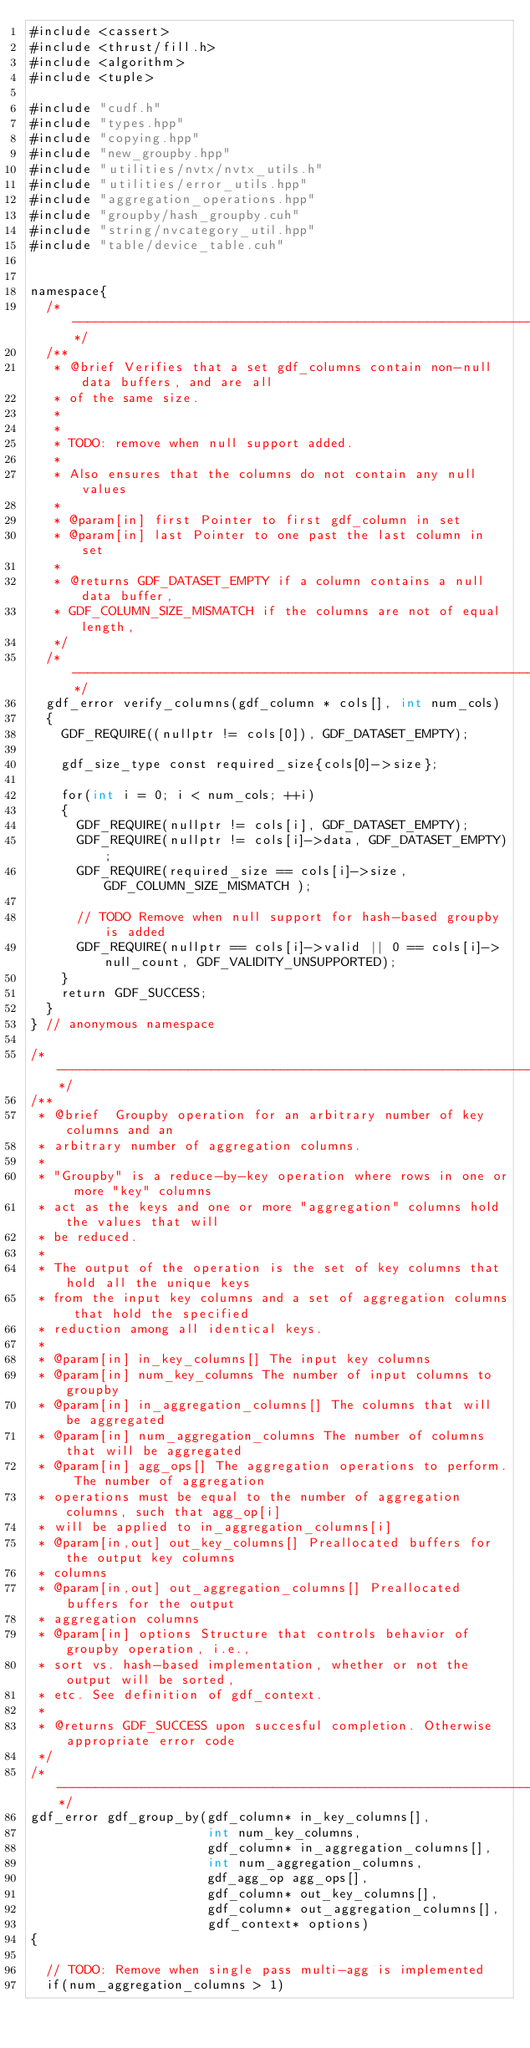<code> <loc_0><loc_0><loc_500><loc_500><_Cuda_>#include <cassert>
#include <thrust/fill.h>
#include <algorithm>
#include <tuple>

#include "cudf.h"
#include "types.hpp"
#include "copying.hpp"
#include "new_groupby.hpp"
#include "utilities/nvtx/nvtx_utils.h"
#include "utilities/error_utils.hpp"
#include "aggregation_operations.hpp"
#include "groupby/hash_groupby.cuh"
#include "string/nvcategory_util.hpp"
#include "table/device_table.cuh"


namespace{
  /* --------------------------------------------------------------------------*/
  /**
   * @brief Verifies that a set gdf_columns contain non-null data buffers, and are all
   * of the same size.
   *
   *
   * TODO: remove when null support added.
   *
   * Also ensures that the columns do not contain any null values
   *
   * @param[in] first Pointer to first gdf_column in set
   * @param[in] last Pointer to one past the last column in set
   *
   * @returns GDF_DATASET_EMPTY if a column contains a null data buffer,
   * GDF_COLUMN_SIZE_MISMATCH if the columns are not of equal length,
   */
  /* ----------------------------------------------------------------------------*/
  gdf_error verify_columns(gdf_column * cols[], int num_cols)
  {
    GDF_REQUIRE((nullptr != cols[0]), GDF_DATASET_EMPTY);

    gdf_size_type const required_size{cols[0]->size};

    for(int i = 0; i < num_cols; ++i)
    {
      GDF_REQUIRE(nullptr != cols[i], GDF_DATASET_EMPTY);
      GDF_REQUIRE(nullptr != cols[i]->data, GDF_DATASET_EMPTY);
      GDF_REQUIRE(required_size == cols[i]->size, GDF_COLUMN_SIZE_MISMATCH );

      // TODO Remove when null support for hash-based groupby is added
      GDF_REQUIRE(nullptr == cols[i]->valid || 0 == cols[i]->null_count, GDF_VALIDITY_UNSUPPORTED);
    }
    return GDF_SUCCESS;
  }
} // anonymous namespace

/* --------------------------------------------------------------------------*/
/**
 * @brief  Groupby operation for an arbitrary number of key columns and an
 * arbitrary number of aggregation columns.
 *
 * "Groupby" is a reduce-by-key operation where rows in one or more "key" columns
 * act as the keys and one or more "aggregation" columns hold the values that will
 * be reduced.
 *
 * The output of the operation is the set of key columns that hold all the unique keys
 * from the input key columns and a set of aggregation columns that hold the specified
 * reduction among all identical keys.
 *
 * @param[in] in_key_columns[] The input key columns
 * @param[in] num_key_columns The number of input columns to groupby
 * @param[in] in_aggregation_columns[] The columns that will be aggregated
 * @param[in] num_aggregation_columns The number of columns that will be aggregated
 * @param[in] agg_ops[] The aggregation operations to perform. The number of aggregation
 * operations must be equal to the number of aggregation columns, such that agg_op[i]
 * will be applied to in_aggregation_columns[i]
 * @param[in,out] out_key_columns[] Preallocated buffers for the output key columns
 * columns
 * @param[in,out] out_aggregation_columns[] Preallocated buffers for the output
 * aggregation columns
 * @param[in] options Structure that controls behavior of groupby operation, i.e.,
 * sort vs. hash-based implementation, whether or not the output will be sorted,
 * etc. See definition of gdf_context.
 *
 * @returns GDF_SUCCESS upon succesful completion. Otherwise appropriate error code
 */
/* ----------------------------------------------------------------------------*/
gdf_error gdf_group_by(gdf_column* in_key_columns[],
                       int num_key_columns,
                       gdf_column* in_aggregation_columns[],
                       int num_aggregation_columns,
                       gdf_agg_op agg_ops[],
                       gdf_column* out_key_columns[],
                       gdf_column* out_aggregation_columns[],
                       gdf_context* options)
{

  // TODO: Remove when single pass multi-agg is implemented
  if(num_aggregation_columns > 1)</code> 